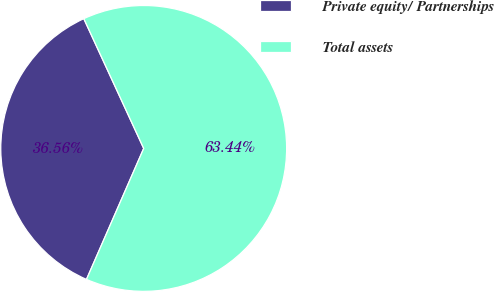Convert chart to OTSL. <chart><loc_0><loc_0><loc_500><loc_500><pie_chart><fcel>Private equity/ Partnerships<fcel>Total assets<nl><fcel>36.56%<fcel>63.44%<nl></chart> 